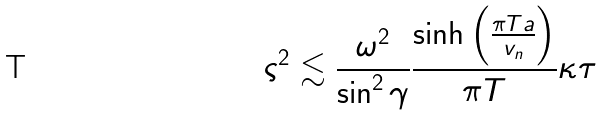Convert formula to latex. <formula><loc_0><loc_0><loc_500><loc_500>\varsigma ^ { 2 } \lesssim \frac { \omega ^ { 2 } } { \sin ^ { 2 } \gamma } \frac { \sinh \left ( \frac { \pi T a } { v _ { n } } \right ) } { \pi T } \kappa \tau</formula> 